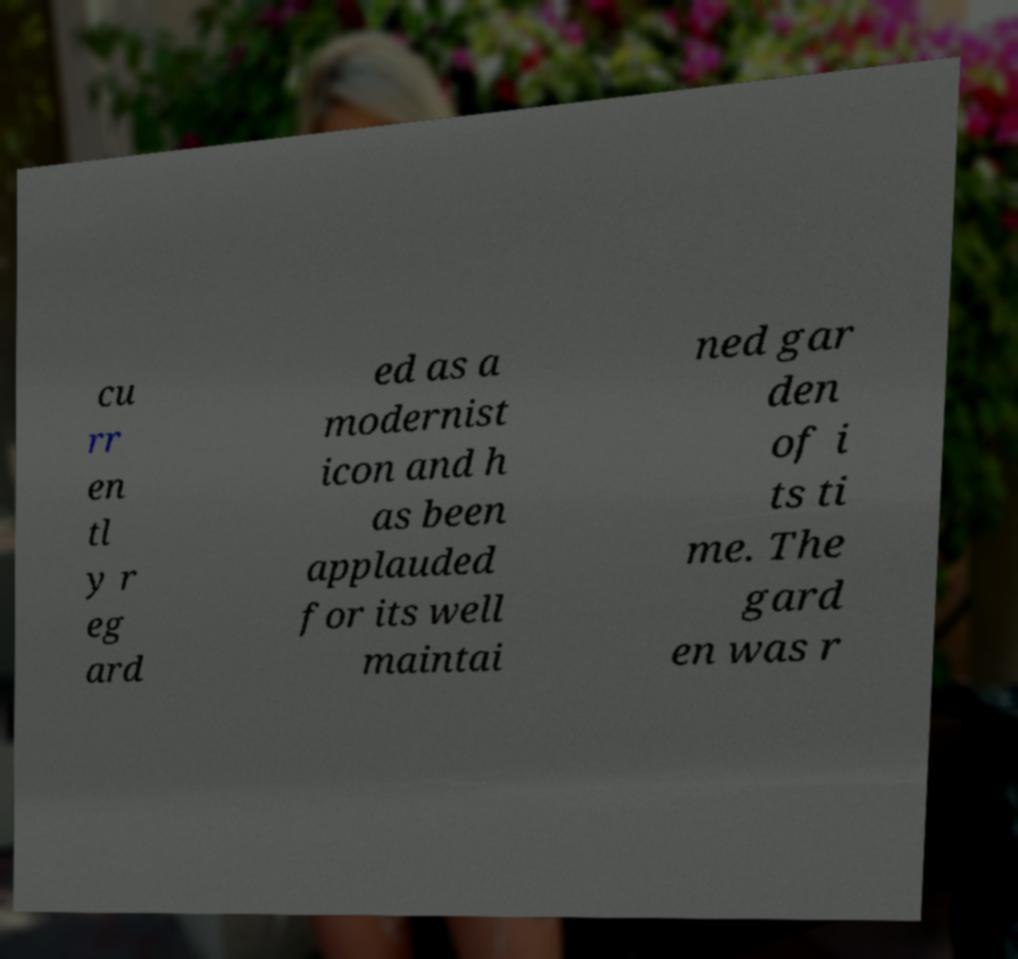For documentation purposes, I need the text within this image transcribed. Could you provide that? cu rr en tl y r eg ard ed as a modernist icon and h as been applauded for its well maintai ned gar den of i ts ti me. The gard en was r 